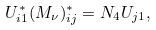Convert formula to latex. <formula><loc_0><loc_0><loc_500><loc_500>U _ { i 1 } ^ { * } ( M _ { \nu } ) _ { i j } ^ { * } = N _ { 4 } U _ { j 1 } ,</formula> 